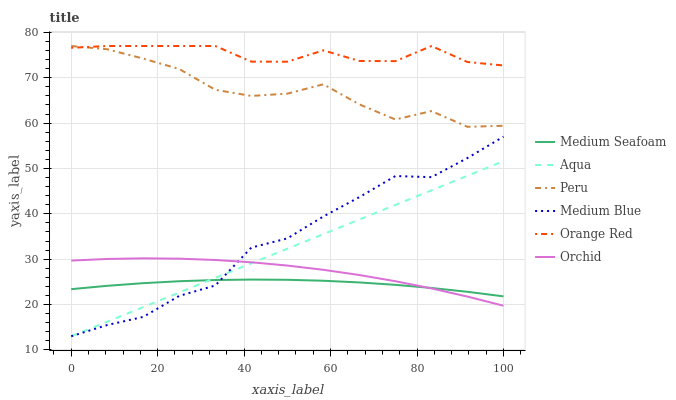Does Medium Seafoam have the minimum area under the curve?
Answer yes or no. Yes. Does Orange Red have the maximum area under the curve?
Answer yes or no. Yes. Does Medium Blue have the minimum area under the curve?
Answer yes or no. No. Does Medium Blue have the maximum area under the curve?
Answer yes or no. No. Is Aqua the smoothest?
Answer yes or no. Yes. Is Peru the roughest?
Answer yes or no. Yes. Is Medium Blue the smoothest?
Answer yes or no. No. Is Medium Blue the roughest?
Answer yes or no. No. Does Aqua have the lowest value?
Answer yes or no. Yes. Does Orange Red have the lowest value?
Answer yes or no. No. Does Peru have the highest value?
Answer yes or no. Yes. Does Medium Blue have the highest value?
Answer yes or no. No. Is Medium Seafoam less than Orange Red?
Answer yes or no. Yes. Is Orange Red greater than Medium Blue?
Answer yes or no. Yes. Does Orange Red intersect Peru?
Answer yes or no. Yes. Is Orange Red less than Peru?
Answer yes or no. No. Is Orange Red greater than Peru?
Answer yes or no. No. Does Medium Seafoam intersect Orange Red?
Answer yes or no. No. 